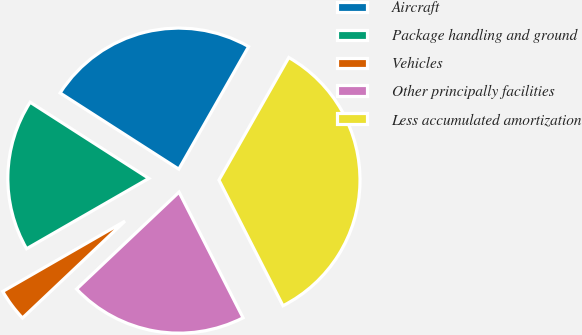Convert chart. <chart><loc_0><loc_0><loc_500><loc_500><pie_chart><fcel>Aircraft<fcel>Package handling and ground<fcel>Vehicles<fcel>Other principally facilities<fcel>Less accumulated amortization<nl><fcel>24.16%<fcel>17.39%<fcel>3.75%<fcel>20.44%<fcel>34.26%<nl></chart> 